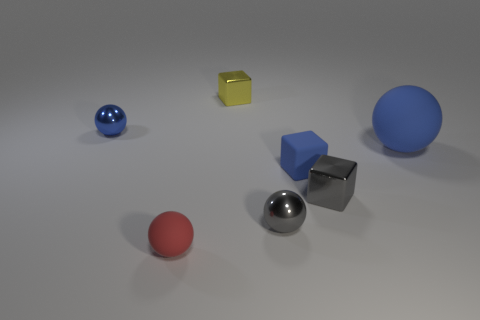What is the shape of the yellow metallic object on the right side of the metallic sphere behind the big thing? cube 